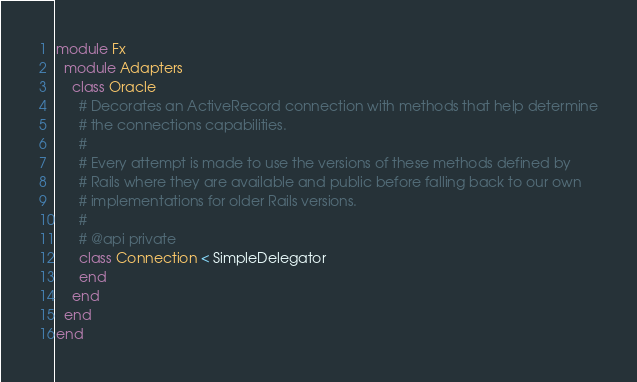Convert code to text. <code><loc_0><loc_0><loc_500><loc_500><_Ruby_>module Fx
  module Adapters
    class Oracle
      # Decorates an ActiveRecord connection with methods that help determine
      # the connections capabilities.
      #
      # Every attempt is made to use the versions of these methods defined by
      # Rails where they are available and public before falling back to our own
      # implementations for older Rails versions.
      #
      # @api private
      class Connection < SimpleDelegator
      end
    end
  end
end
</code> 